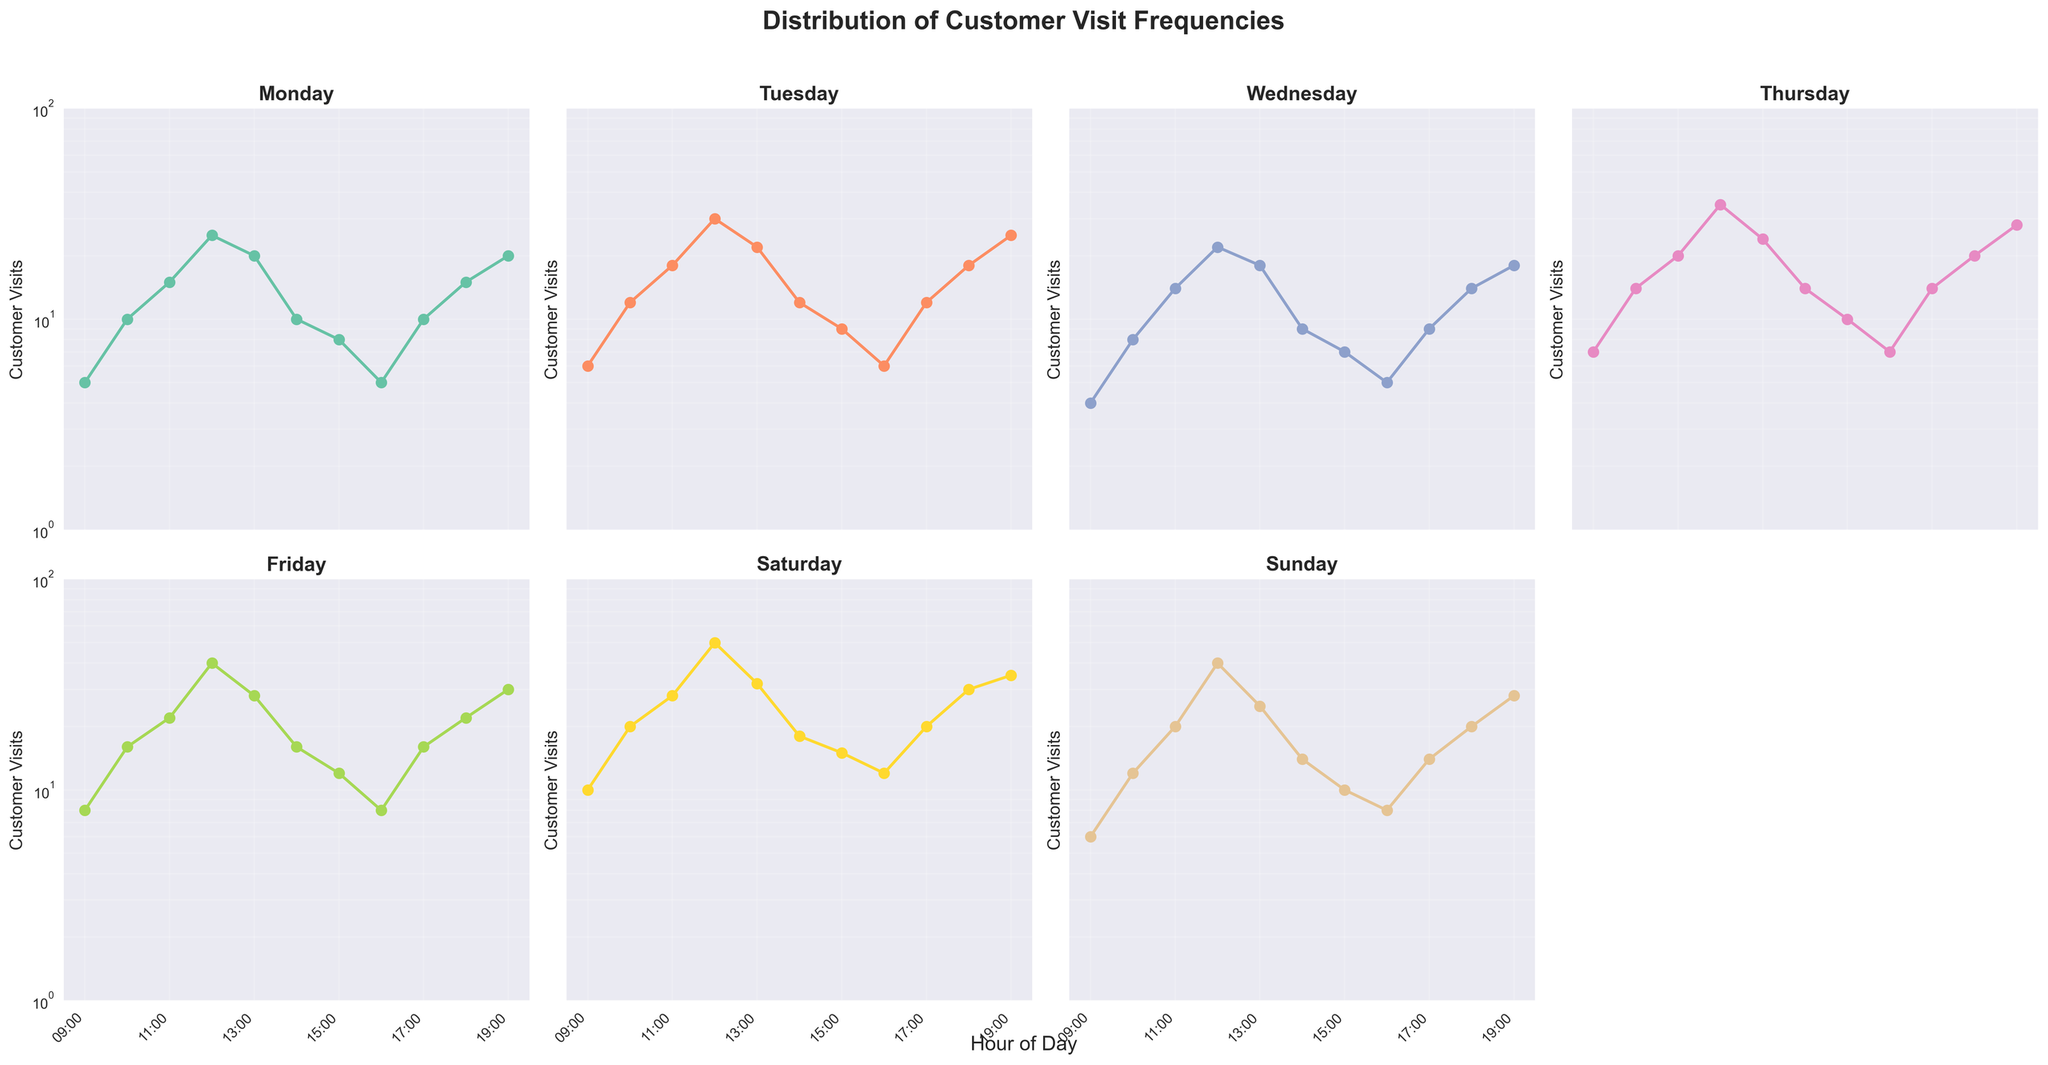Which weekday has the highest peak in customer visits? Upon inspecting each subplot, Saturday has the highest number of customer visits peaking at 50 during the 12:00 to 13:00 hour.
Answer: Saturday At what hour does Sunday reach its peak in customer visits? The subplot for Sunday shows the highest number of customer visits during the 12:00 to 13:00 hour, peaking at 40 visits.
Answer: 12:00 How do the peak customer visit hours on weekdays compare to those on weekends? Both weekday and weekend plots show that peak customer visits occur most frequently around midday (12:00 to 13:00). However, the peak values on weekends (Saturday and Sunday) tend to be higher than those on weekdays.
Answer: Midday, higher on weekends What is the trend in customer visits on Tuesday from 10:00 to 15:00? The subplot for Tuesday shows a rising trend in customer visits from 10:00, peaking at 30 by 12:00, then gradually decreasing to 9 by 15:00.
Answer: Rise, peak at 12:00, gradual decrease Which day has the most significant increase in customer visits from 09:00 to 12:00? Friday shows the most significant increase in customer visits from 8 at 09:00 to 40 at 12:00.
Answer: Friday How does the distribution of customer visits on Wednesday compare to that on Monday at 17:00 and 18:00? On Monday, there are 10 customer visits at 17:00 and 15 at 18:00. On Wednesday, there are 9 customer visits at 17:00 and 14 at 18:00. The numbers are slightly lower on Wednesday.
Answer: Slightly lower on Wednesday What is the total number of customer visits for Monday? By summing up the customer visit numbers for each hour on Monday (5 + 10 + 15 + 25 + 20 + 10 + 8 + 5 + 10 + 15 + 20), the total is 143.
Answer: 143 Which hour shows the least customer visits overall in the entire week? Across all the subplots, 09:00 shows the least number of customer visits through the week, with visits ranging from 4 to 10 depending on the day.
Answer: 09:00 How consistent are customer visits between 14:00 to 16:00 across different days? From 14:00 to 16:00, the visit numbers per day are: Monday (10, 8, 5), Tuesday (12, 9, 6), Wednesday (9, 7, 5), Thursday (14, 10, 7), Friday (16, 12, 8), Saturday (18, 15, 12), Sunday (14, 10, 8). The numbers generally decline from 14:00 to 16:00, with a fairly consistent pattern albeit lower on weekdays and higher on weekends.
Answer: Declining, fairly consistent 